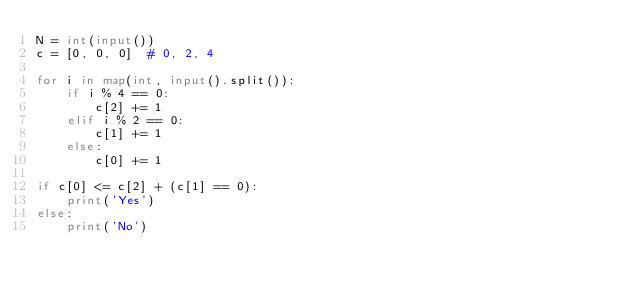<code> <loc_0><loc_0><loc_500><loc_500><_Python_>N = int(input())
c = [0, 0, 0]  # 0, 2, 4

for i in map(int, input().split()):
    if i % 4 == 0:
        c[2] += 1
    elif i % 2 == 0:
        c[1] += 1
    else:
        c[0] += 1

if c[0] <= c[2] + (c[1] == 0):
    print('Yes')
else:
    print('No')</code> 